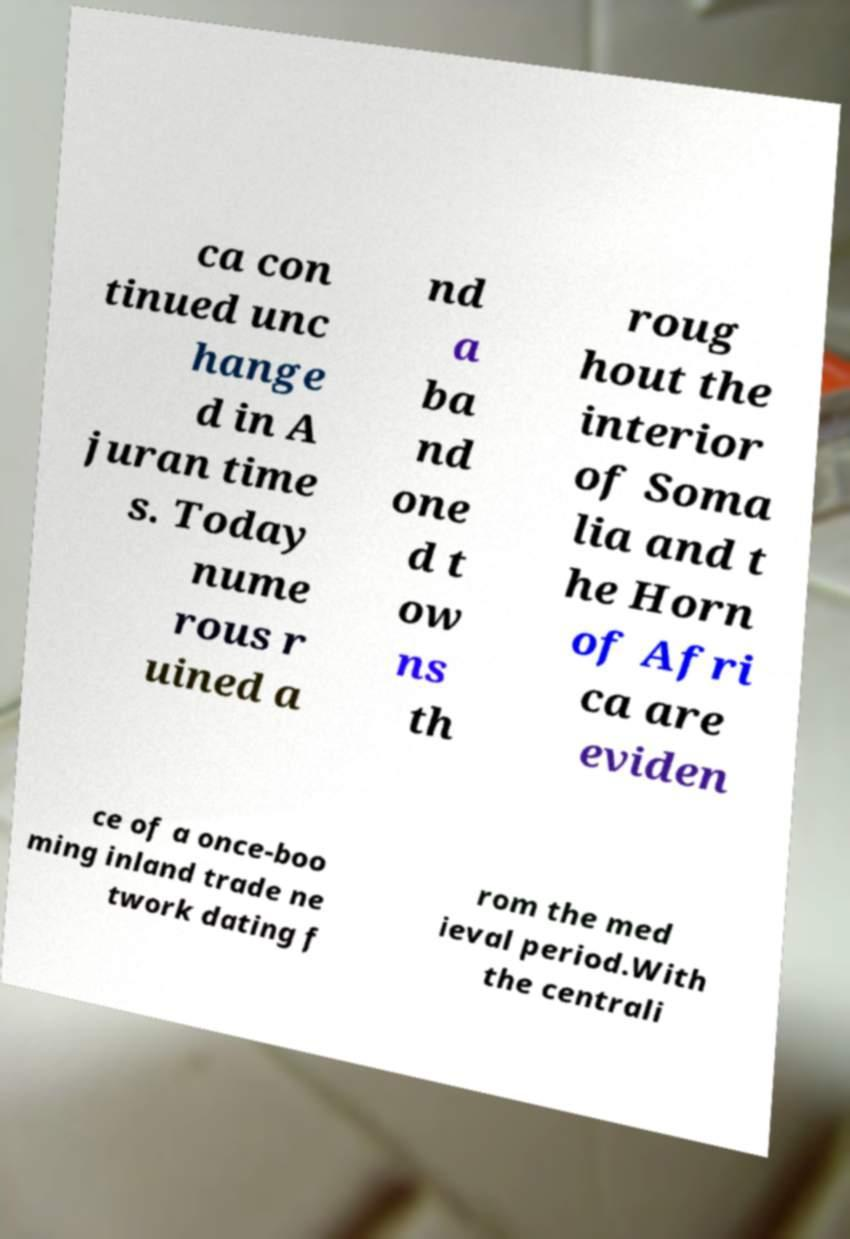Can you read and provide the text displayed in the image?This photo seems to have some interesting text. Can you extract and type it out for me? ca con tinued unc hange d in A juran time s. Today nume rous r uined a nd a ba nd one d t ow ns th roug hout the interior of Soma lia and t he Horn of Afri ca are eviden ce of a once-boo ming inland trade ne twork dating f rom the med ieval period.With the centrali 